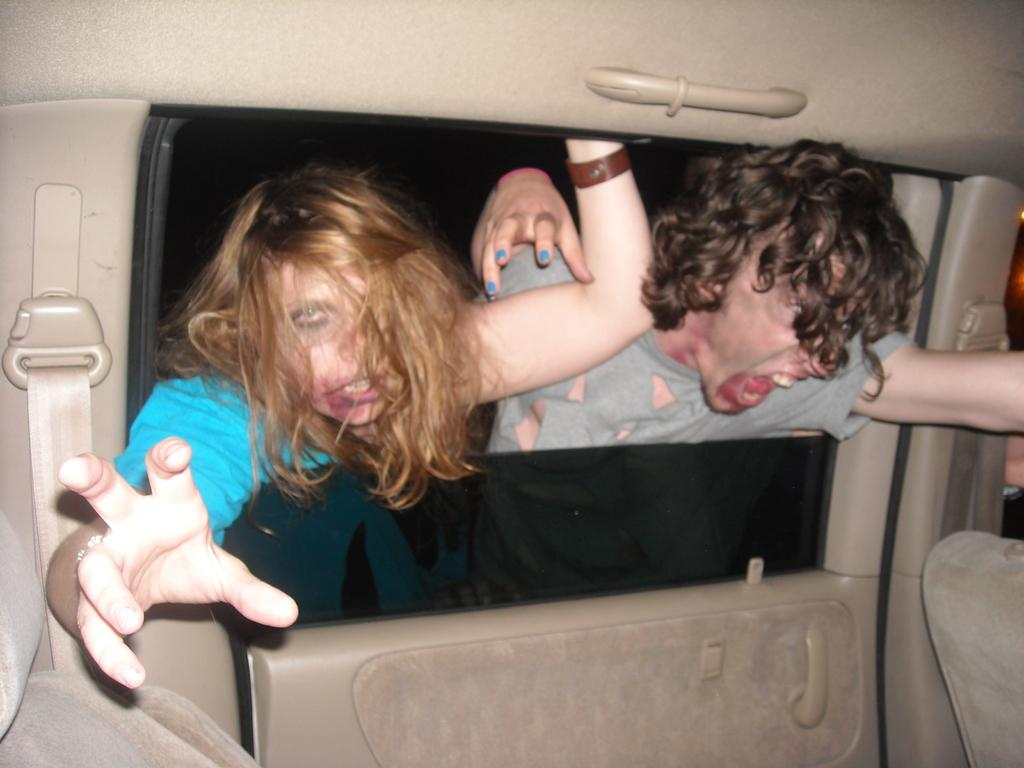How many people are present in the image? There is a woman and a man present in the image. What is the setting of the image? The image shows the inside view of a vehicle. What type of nut is being used to tighten the faucet in the image? There is no nut or faucet present in the image; it shows the inside view of a vehicle with a woman and a man. 